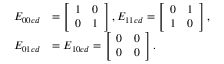Convert formula to latex. <formula><loc_0><loc_0><loc_500><loc_500>\begin{array} { r l } { E _ { 0 0 c d } } & { = \left [ \begin{array} { l l } { 1 } & { 0 } \\ { 0 } & { 1 } \end{array} \right ] , E _ { 1 1 c d } = \left [ \begin{array} { l l } { 0 } & { 1 } \\ { 1 } & { 0 } \end{array} \right ] , } \\ { E _ { 0 1 c d } } & { = E _ { 1 0 c d } = \left [ \begin{array} { l l } { 0 } & { 0 } \\ { 0 } & { 0 } \end{array} \right ] . } \end{array}</formula> 